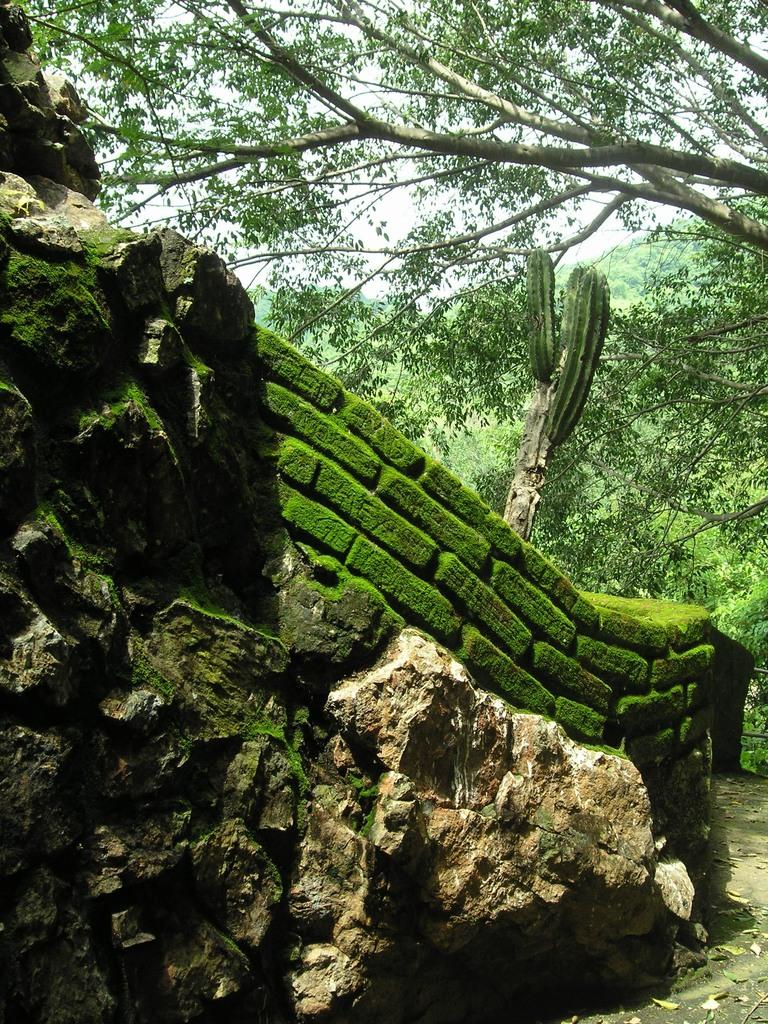What type of natural formation can be seen in the image? There are rocks in the image. What man-made structure is present in the image? There is a brick wall in the image. What type of plant is visible in the image? There is a cactus plant in the image. What can be seen in the background of the image? There are trees in the background of the image. How is the water being distributed to the plants in the image? There is no mention of water or any distribution system in the image; it features rocks, a brick wall, a cactus plant, and trees. What type of pump is used to water the cactus plant in the image? There is no pump present in the image; the cactus plant is shown without any watering system. 